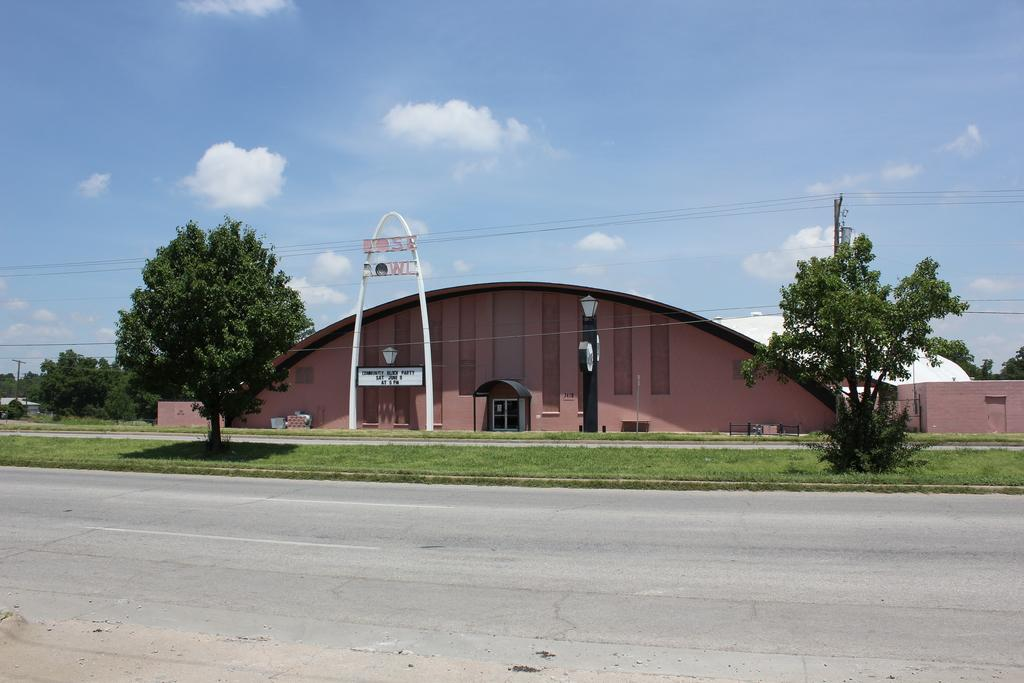What is the main feature of the image? There is a road in the image. What can be seen in the sky in the image? There are clouds in the image. What is visible in the background of the image? The sky is visible in the image. What type of structure is present in the image? There is a home or building in the image. What type of lettuce is being used as a roof for the building in the image? There is no lettuce present in the image, and the building's roof is not made of lettuce. 